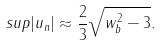Convert formula to latex. <formula><loc_0><loc_0><loc_500><loc_500>s u p | u _ { n } | \approx \frac { 2 } { 3 } \sqrt { w _ { b } ^ { 2 } - 3 } .</formula> 